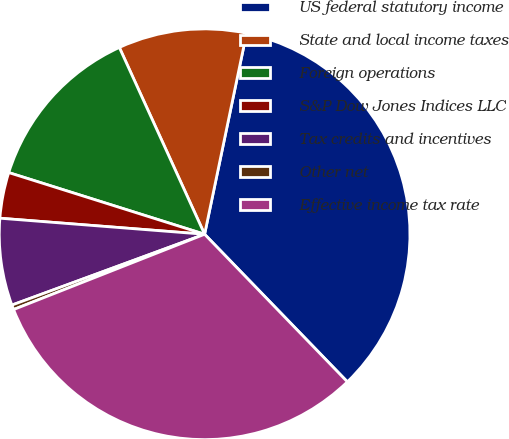<chart> <loc_0><loc_0><loc_500><loc_500><pie_chart><fcel>US federal statutory income<fcel>State and local income taxes<fcel>Foreign operations<fcel>S&P Dow Jones Indices LLC<fcel>Tax credits and incentives<fcel>Other net<fcel>Effective income tax rate<nl><fcel>34.49%<fcel>10.09%<fcel>13.33%<fcel>3.61%<fcel>6.85%<fcel>0.37%<fcel>31.26%<nl></chart> 